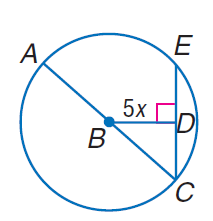Question: In \odot B, the diameter is 20 units long, and m \angle A C E = 45. Find x.
Choices:
A. \sqrt { 2 }
B. 2
C. 4
D. 5 \sqrt { 2 }
Answer with the letter. Answer: A 